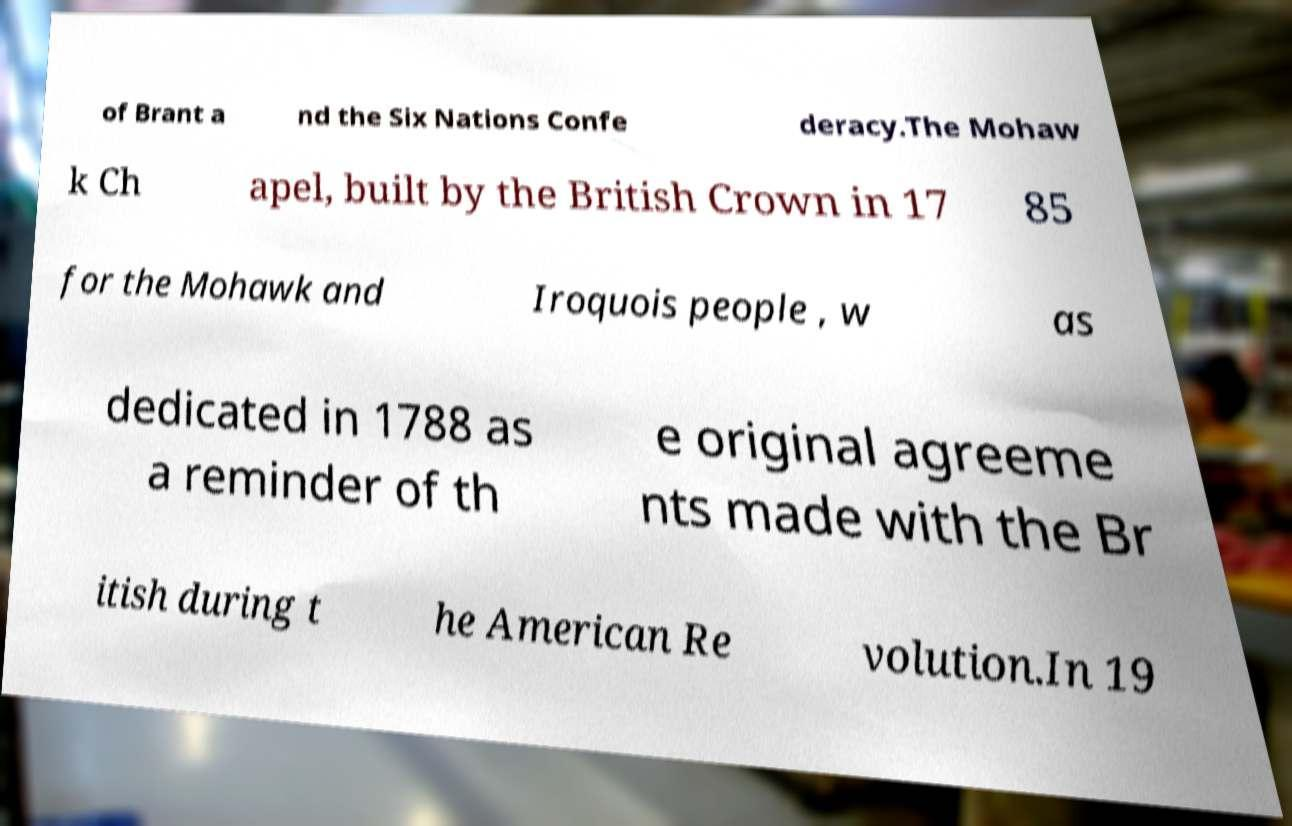Please identify and transcribe the text found in this image. of Brant a nd the Six Nations Confe deracy.The Mohaw k Ch apel, built by the British Crown in 17 85 for the Mohawk and Iroquois people , w as dedicated in 1788 as a reminder of th e original agreeme nts made with the Br itish during t he American Re volution.In 19 